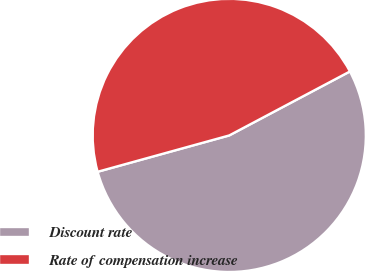<chart> <loc_0><loc_0><loc_500><loc_500><pie_chart><fcel>Discount rate<fcel>Rate of compensation increase<nl><fcel>53.47%<fcel>46.53%<nl></chart> 